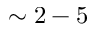<formula> <loc_0><loc_0><loc_500><loc_500>\sim 2 - 5</formula> 